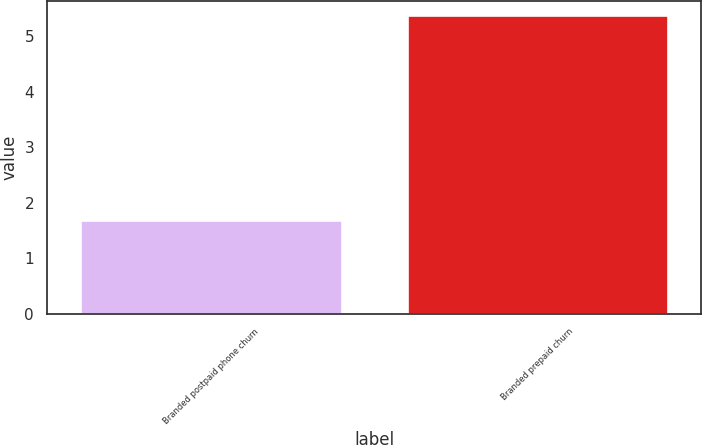Convert chart. <chart><loc_0><loc_0><loc_500><loc_500><bar_chart><fcel>Branded postpaid phone churn<fcel>Branded prepaid churn<nl><fcel>1.69<fcel>5.37<nl></chart> 